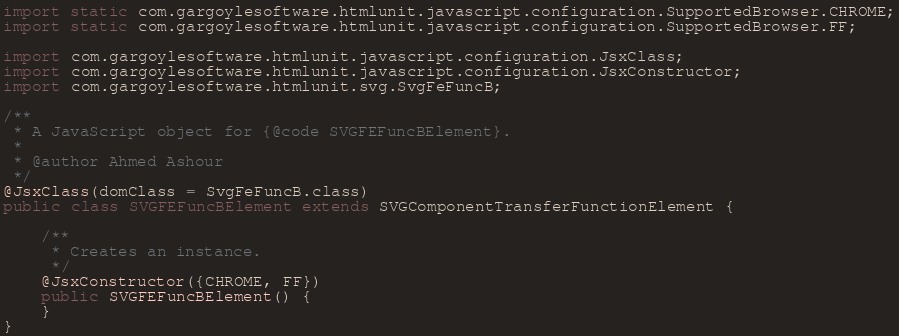<code> <loc_0><loc_0><loc_500><loc_500><_Java_>import static com.gargoylesoftware.htmlunit.javascript.configuration.SupportedBrowser.CHROME;
import static com.gargoylesoftware.htmlunit.javascript.configuration.SupportedBrowser.FF;

import com.gargoylesoftware.htmlunit.javascript.configuration.JsxClass;
import com.gargoylesoftware.htmlunit.javascript.configuration.JsxConstructor;
import com.gargoylesoftware.htmlunit.svg.SvgFeFuncB;

/**
 * A JavaScript object for {@code SVGFEFuncBElement}.
 *
 * @author Ahmed Ashour
 */
@JsxClass(domClass = SvgFeFuncB.class)
public class SVGFEFuncBElement extends SVGComponentTransferFunctionElement {

    /**
     * Creates an instance.
     */
    @JsxConstructor({CHROME, FF})
    public SVGFEFuncBElement() {
    }
}
</code> 